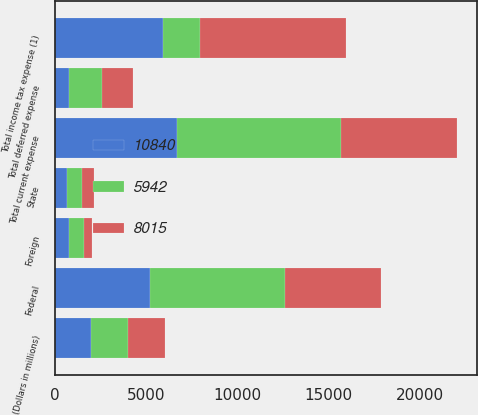Convert chart. <chart><loc_0><loc_0><loc_500><loc_500><stacked_bar_chart><ecel><fcel>(Dollars in millions)<fcel>Federal<fcel>State<fcel>Foreign<fcel>Total current expense<fcel>Total deferred expense<fcel>Total income tax expense (1)<nl><fcel>10840<fcel>2007<fcel>5210<fcel>681<fcel>804<fcel>6695<fcel>753<fcel>5942<nl><fcel>5942<fcel>2006<fcel>7398<fcel>796<fcel>796<fcel>8990<fcel>1850<fcel>2005.5<nl><fcel>8015<fcel>2005<fcel>5229<fcel>676<fcel>415<fcel>6320<fcel>1695<fcel>8015<nl></chart> 